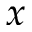<formula> <loc_0><loc_0><loc_500><loc_500>x</formula> 